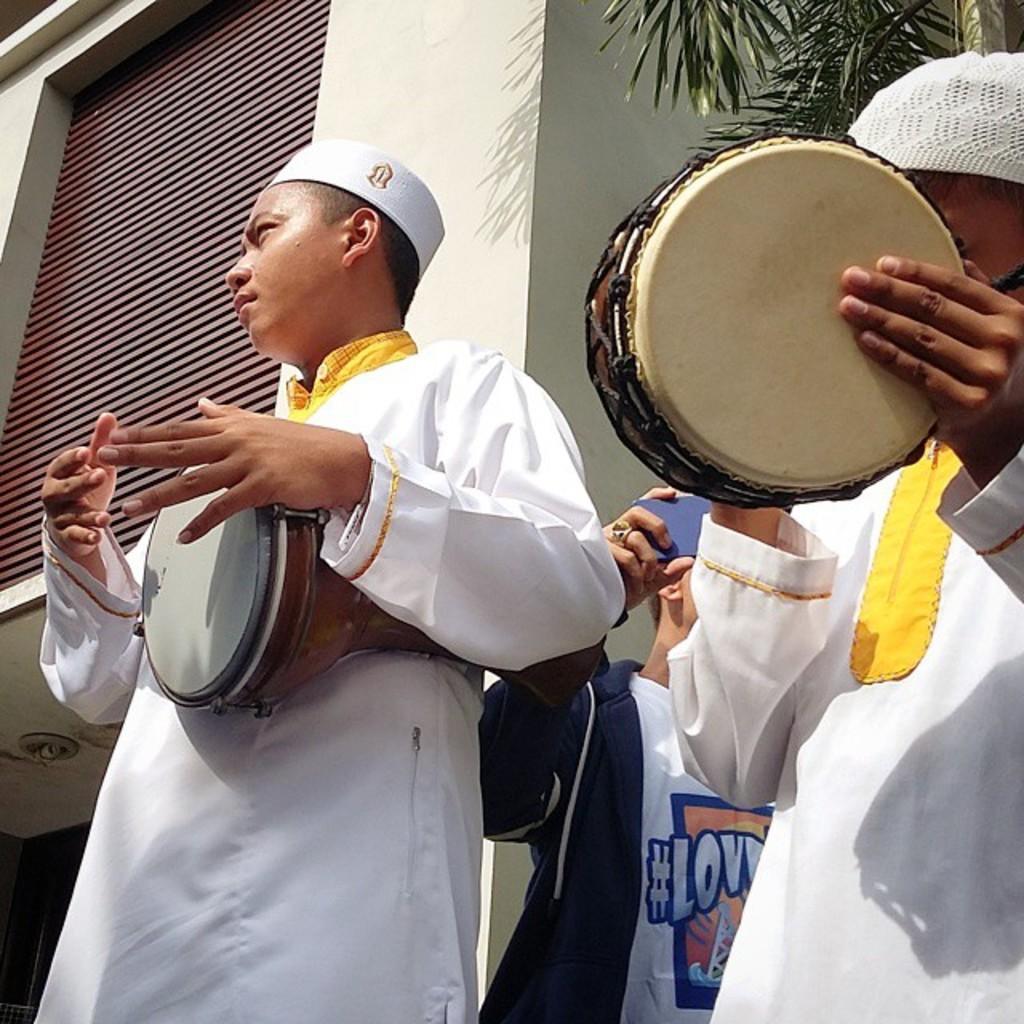In one or two sentences, can you explain what this image depicts? In this picture there is a man who is playing the drums by holding in his hand and wearing a white color kurti and a white color hat and at the right side of him there is another person playing the drum by holding in his hand and at back ground there is a building, tree,and a person holding a mobile phone in his hand. 